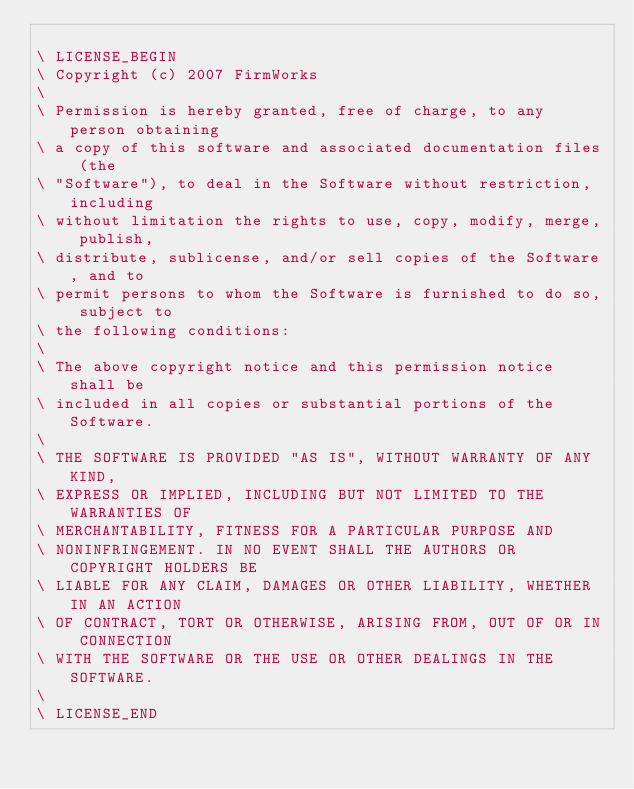Convert code to text. <code><loc_0><loc_0><loc_500><loc_500><_Forth_>
\ LICENSE_BEGIN
\ Copyright (c) 2007 FirmWorks
\ 
\ Permission is hereby granted, free of charge, to any person obtaining
\ a copy of this software and associated documentation files (the
\ "Software"), to deal in the Software without restriction, including
\ without limitation the rights to use, copy, modify, merge, publish,
\ distribute, sublicense, and/or sell copies of the Software, and to
\ permit persons to whom the Software is furnished to do so, subject to
\ the following conditions:
\ 
\ The above copyright notice and this permission notice shall be
\ included in all copies or substantial portions of the Software.
\ 
\ THE SOFTWARE IS PROVIDED "AS IS", WITHOUT WARRANTY OF ANY KIND,
\ EXPRESS OR IMPLIED, INCLUDING BUT NOT LIMITED TO THE WARRANTIES OF
\ MERCHANTABILITY, FITNESS FOR A PARTICULAR PURPOSE AND
\ NONINFRINGEMENT. IN NO EVENT SHALL THE AUTHORS OR COPYRIGHT HOLDERS BE
\ LIABLE FOR ANY CLAIM, DAMAGES OR OTHER LIABILITY, WHETHER IN AN ACTION
\ OF CONTRACT, TORT OR OTHERWISE, ARISING FROM, OUT OF OR IN CONNECTION
\ WITH THE SOFTWARE OR THE USE OR OTHER DEALINGS IN THE SOFTWARE.
\
\ LICENSE_END
</code> 